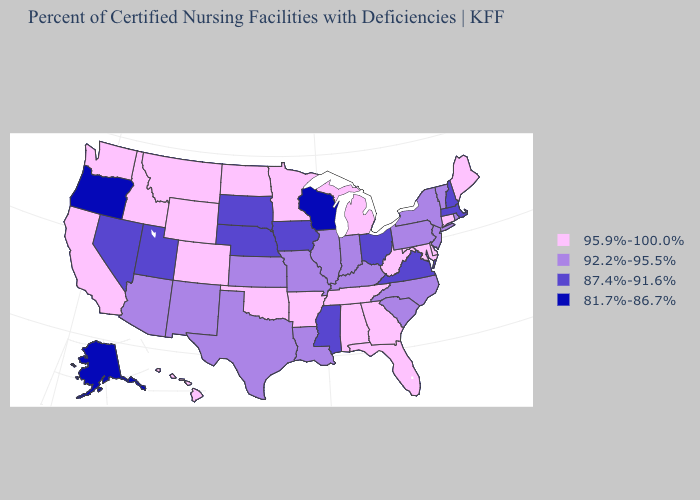Among the states that border Pennsylvania , does Ohio have the highest value?
Keep it brief. No. Among the states that border Oregon , which have the lowest value?
Write a very short answer. Nevada. What is the value of Connecticut?
Answer briefly. 95.9%-100.0%. Does Tennessee have the lowest value in the USA?
Short answer required. No. Name the states that have a value in the range 81.7%-86.7%?
Keep it brief. Alaska, Oregon, Wisconsin. Does Nebraska have a higher value than Texas?
Quick response, please. No. Does Georgia have the lowest value in the South?
Write a very short answer. No. What is the value of Maryland?
Concise answer only. 95.9%-100.0%. What is the value of Pennsylvania?
Be succinct. 92.2%-95.5%. What is the value of Washington?
Answer briefly. 95.9%-100.0%. What is the highest value in the West ?
Keep it brief. 95.9%-100.0%. Name the states that have a value in the range 92.2%-95.5%?
Concise answer only. Arizona, Illinois, Indiana, Kansas, Kentucky, Louisiana, Missouri, New Jersey, New Mexico, New York, North Carolina, Pennsylvania, Rhode Island, South Carolina, Texas, Vermont. Among the states that border Kansas , does Oklahoma have the highest value?
Give a very brief answer. Yes. Does Florida have the same value as Hawaii?
Quick response, please. Yes. 